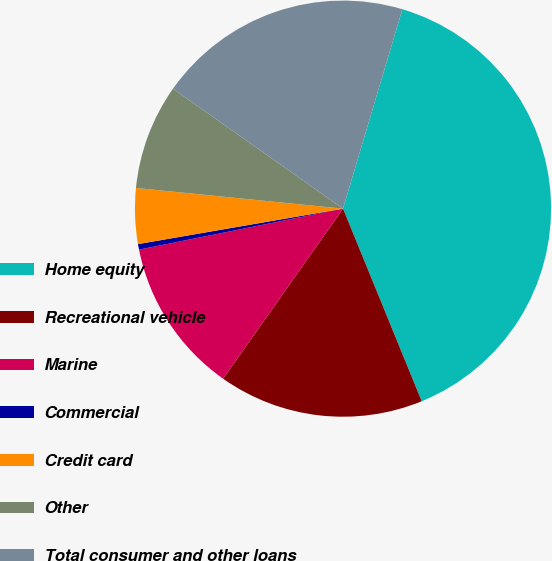Convert chart. <chart><loc_0><loc_0><loc_500><loc_500><pie_chart><fcel>Home equity<fcel>Recreational vehicle<fcel>Marine<fcel>Commercial<fcel>Credit card<fcel>Other<fcel>Total consumer and other loans<nl><fcel>39.22%<fcel>15.95%<fcel>12.07%<fcel>0.43%<fcel>4.31%<fcel>8.19%<fcel>19.83%<nl></chart> 